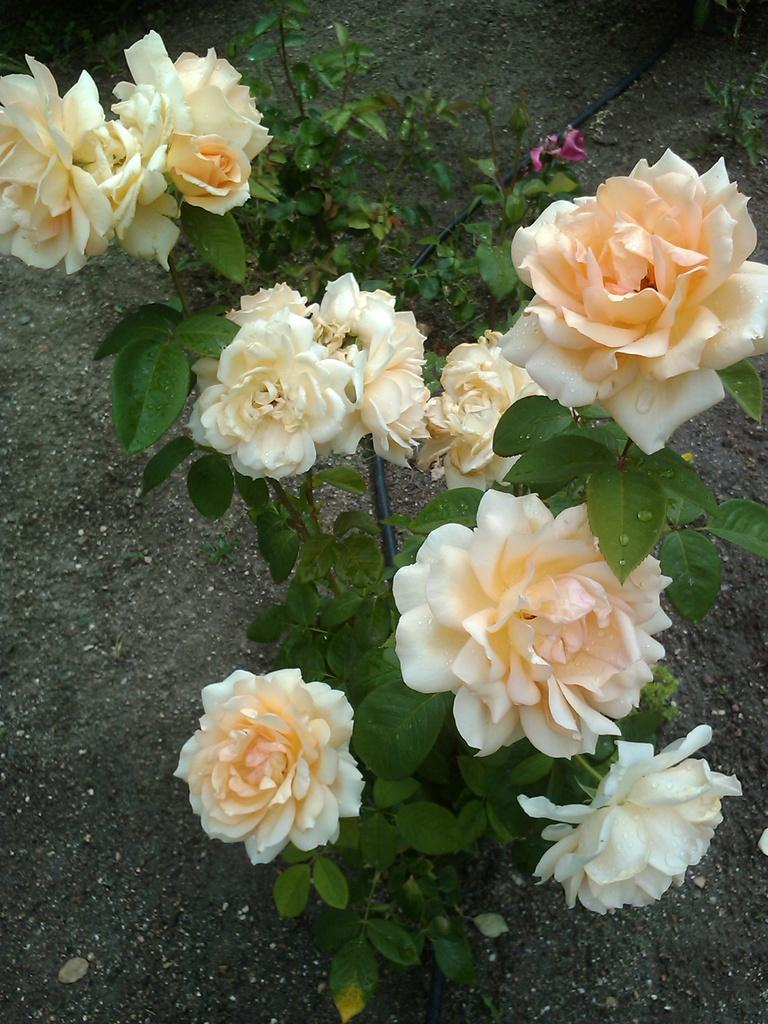What type of flowers are in the foreground of the image? There are rose flowers in the foreground of the image. Where are the rose flowers located? The rose flowers are on a plant. What can be seen in the background of the image? There is ground visible in the background of the image, as well as a black pipe. How does the fog affect the visibility of the bear in the image? There is no fog or bear present in the image. 